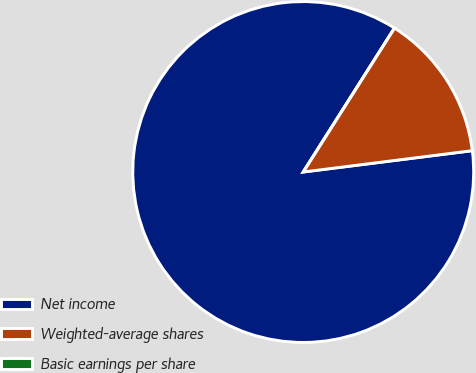<chart> <loc_0><loc_0><loc_500><loc_500><pie_chart><fcel>Net income<fcel>Weighted-average shares<fcel>Basic earnings per share<nl><fcel>85.99%<fcel>14.01%<fcel>0.0%<nl></chart> 